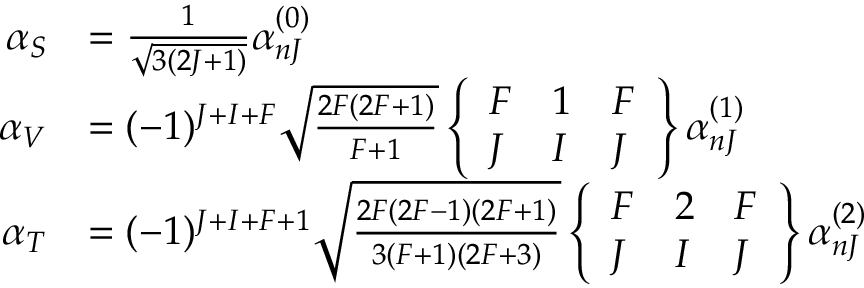<formula> <loc_0><loc_0><loc_500><loc_500>\begin{array} { r l } { \alpha _ { S } } & { = \frac { 1 } { \sqrt { 3 ( 2 J + 1 ) } } \alpha _ { n J } ^ { ( 0 ) } } \\ { \alpha _ { V } } & { = ( - 1 ) ^ { J + I + F } \sqrt { \frac { 2 F ( 2 F + 1 ) } { F + 1 } } \left \{ \begin{array} { l l l } { F } & { 1 } & { F } \\ { J } & { I } & { J } \end{array} \right \} \alpha _ { n J } ^ { ( 1 ) } } \\ { \alpha _ { T } } & { = ( - 1 ) ^ { J + I + F + 1 } \sqrt { \frac { 2 F ( 2 F - 1 ) ( 2 F + 1 ) } { 3 ( F + 1 ) ( 2 F + 3 ) } } \left \{ \begin{array} { l l l } { F } & { 2 } & { F } \\ { J } & { I } & { J } \end{array} \right \} \alpha _ { n J } ^ { ( 2 ) } } \end{array}</formula> 